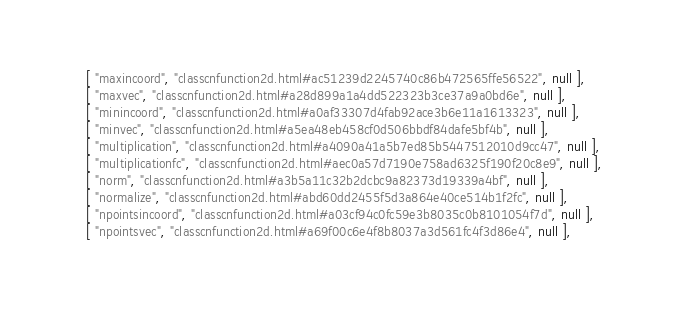Convert code to text. <code><loc_0><loc_0><loc_500><loc_500><_JavaScript_>    [ "maxincoord", "classcnfunction2d.html#ac51239d2245740c86b472565ffe56522", null ],
    [ "maxvec", "classcnfunction2d.html#a28d899a1a4dd522323b3ce37a9a0bd6e", null ],
    [ "minincoord", "classcnfunction2d.html#a0af33307d4fab92ace3b6e11a1613323", null ],
    [ "minvec", "classcnfunction2d.html#a5ea48eb458cf0d506bbdf84dafe5bf4b", null ],
    [ "multiplication", "classcnfunction2d.html#a4090a41a5b7ed85b5447512010d9cc47", null ],
    [ "multiplicationfc", "classcnfunction2d.html#aec0a57d7190e758ad6325f190f20c8e9", null ],
    [ "norm", "classcnfunction2d.html#a3b5a11c32b2dcbc9a82373d19339a4bf", null ],
    [ "normalize", "classcnfunction2d.html#abd60dd2455f5d3a864e40ce514b1f2fc", null ],
    [ "npointsincoord", "classcnfunction2d.html#a03cf94c0fc59e3b8035c0b8101054f7d", null ],
    [ "npointsvec", "classcnfunction2d.html#a69f00c6e4f8b8037a3d561fc4f3d86e4", null ],</code> 